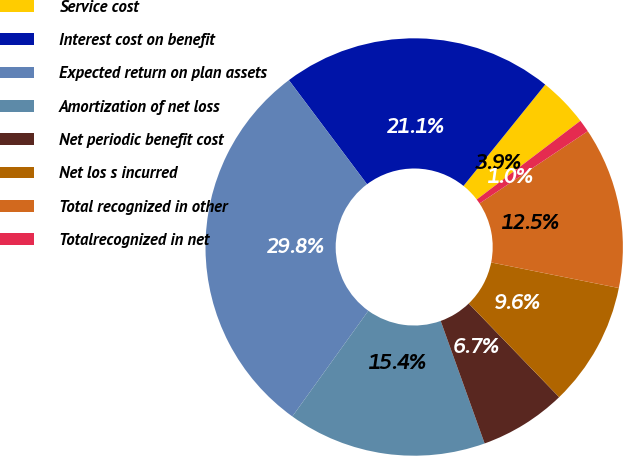Convert chart. <chart><loc_0><loc_0><loc_500><loc_500><pie_chart><fcel>Service cost<fcel>Interest cost on benefit<fcel>Expected return on plan assets<fcel>Amortization of net loss<fcel>Net periodic benefit cost<fcel>Net los s incurred<fcel>Total recognized in other<fcel>Totalrecognized in net<nl><fcel>3.86%<fcel>21.05%<fcel>29.82%<fcel>15.4%<fcel>6.74%<fcel>9.63%<fcel>12.51%<fcel>0.97%<nl></chart> 